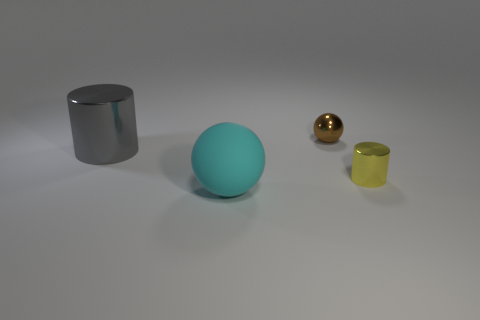Is there any other thing that has the same material as the cyan sphere?
Keep it short and to the point. No. Is the material of the yellow object the same as the cyan sphere?
Offer a terse response. No. Is the number of tiny metal cylinders that are to the right of the tiny yellow thing the same as the number of metal blocks?
Give a very brief answer. Yes. How many cyan spheres have the same material as the big cyan object?
Make the answer very short. 0. Are there fewer large metallic cylinders than tiny green objects?
Offer a very short reply. No. Do the cylinder that is to the left of the yellow metallic cylinder and the shiny sphere have the same color?
Keep it short and to the point. No. How many things are in front of the small metal object that is in front of the sphere behind the large cyan matte thing?
Provide a short and direct response. 1. There is a matte thing; what number of matte objects are in front of it?
Offer a terse response. 0. What is the color of the other object that is the same shape as the big matte thing?
Offer a very short reply. Brown. There is a object that is both to the right of the big cyan matte object and in front of the tiny ball; what material is it made of?
Make the answer very short. Metal. 